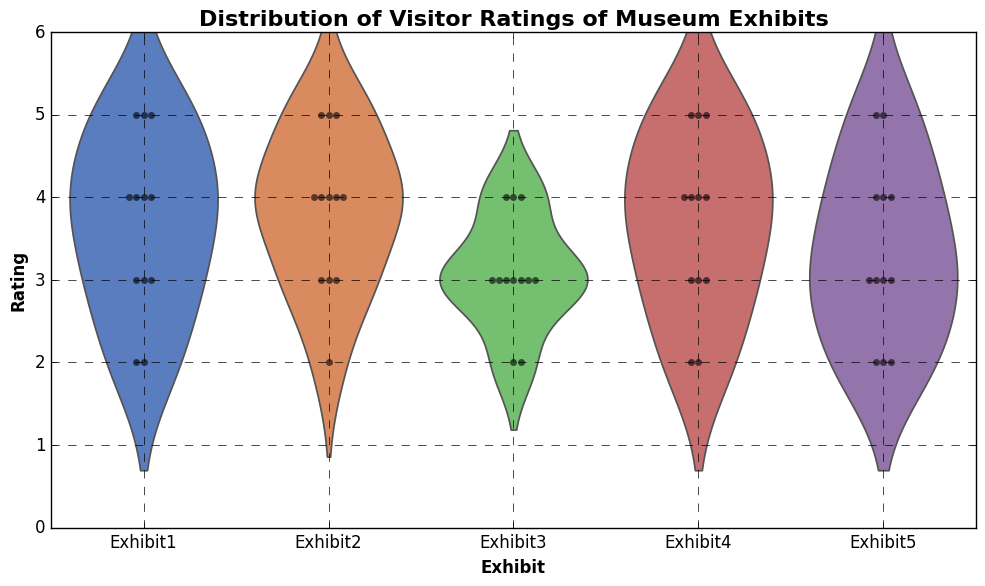Which exhibit has the widest distribution of ratings? The width of each violin plot indicates the distribution of ratings for each exhibit, and Exhibit1 has the widest spread, showing a larger spread in visitor ratings.
Answer: Exhibit1 Which exhibit received the most uniformly consistent ratings? The violin plot for Exhibit3 is the narrowest, indicating that most ratings are clustered around a central value with less variation.
Answer: Exhibit3 What is the most common rating for Exhibit4? By observing the density and height of the plot, the most dense part of Exhibit4's violin plot is around the ratings of 4 and 5, indicating these are the most common ratings for this exhibit.
Answer: 4 and 5 How do the ratings for Exhibit5 differ from those of Exhibit2? Exhibit2's ratings show two peaks around 3 and 4, indicating bimodal distribution with more variability. In contrast, Exhibit5's ratings are spread more evenly across lower ratings, showing variability with somewhat consistent lower and higher ratings.
Answer: Exhibit2 has bimodal distribution; Exhibit5 has more evenly spread ratings Which exhibit has the highest median rating? The median is indicated by the central tendency of the swarm plot dots. Exhibits 1 and 4 show high concentration of values at upper end with similar distribution, with Exhibit4 showing consistent high ratings.
Answer: Exhibit4 What is the approximate range of ratings for Exhibit1? The ends of Exhibit1's violin plot extend from around rating 2 to rating 5, indicating this is the range within which most ratings fall.
Answer: 2 to 5 Which exhibit appears to have a skewed distribution and in which direction? The shape of the violin plot for Exhibit2 appears skewed to the left, as there are more ratings concentrated in the lower range (2 and 3) with a few higher ratings.
Answer: Exhibit2, skewed left Compare the density of ratings for Exhibit3 and Exhibit4. Exhibit3 has a higher density around the rating of 3, while Exhibit4 has a higher density around 4 and 5, suggesting greater satisfaction with Exhibit4.
Answer: Exhibit3: dense around 3; Exhibit4: dense around 4, 5 What is the overall median rating across all exhibits? Estimating the median values shown by each exhibit's plot and averaging them, ratings hover around 3 and 4 for most exhibits, pointing to an overall median around 3.5-4.0.
Answer: 3.5-4.0 